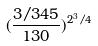Convert formula to latex. <formula><loc_0><loc_0><loc_500><loc_500>( \frac { 3 / 3 4 5 } { 1 3 0 } ) ^ { 2 ^ { 3 } / 4 }</formula> 